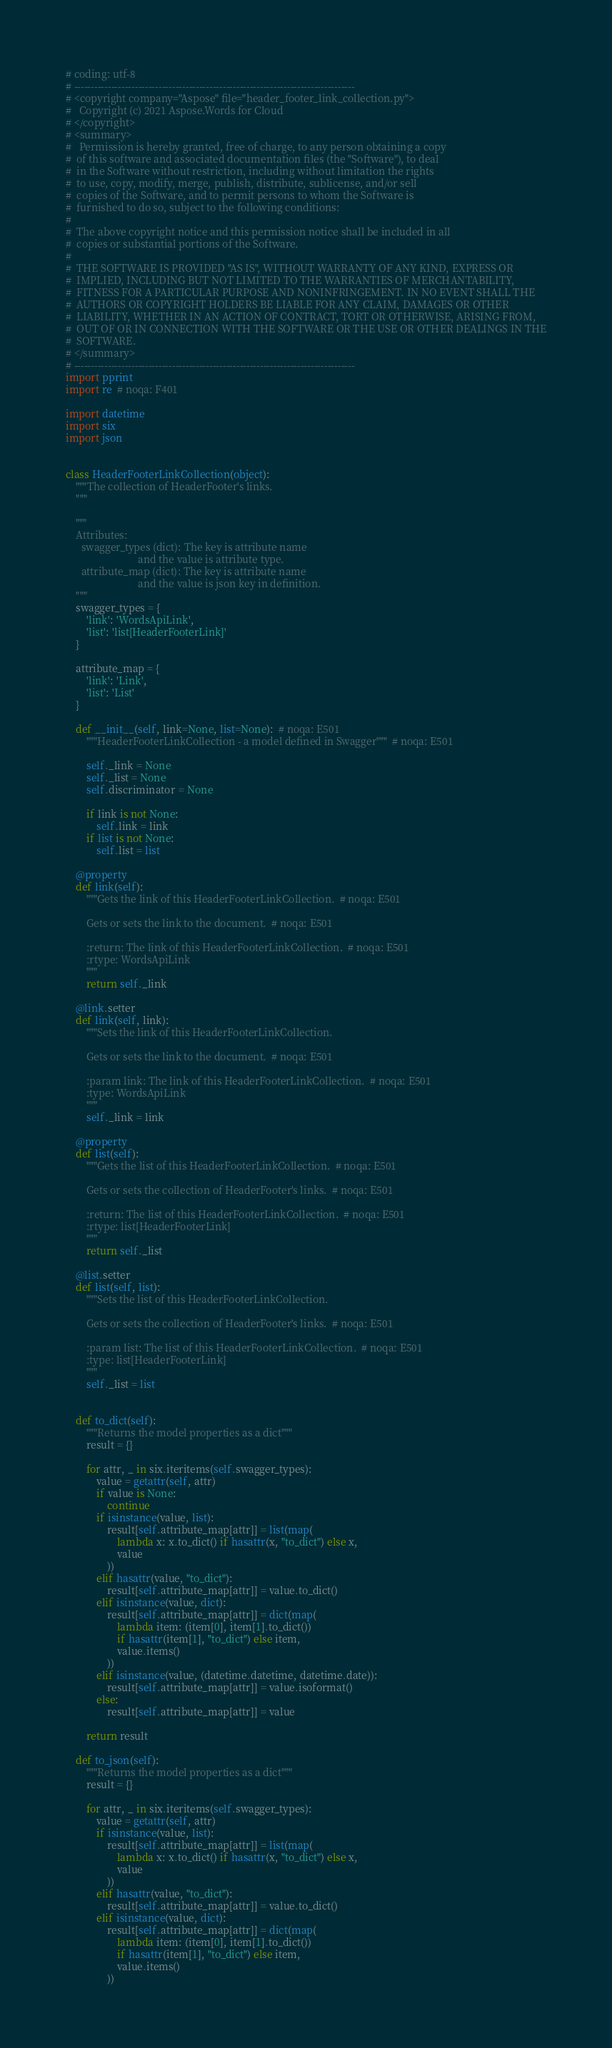Convert code to text. <code><loc_0><loc_0><loc_500><loc_500><_Python_># coding: utf-8
# -----------------------------------------------------------------------------------
# <copyright company="Aspose" file="header_footer_link_collection.py">
#   Copyright (c) 2021 Aspose.Words for Cloud
# </copyright>
# <summary>
#   Permission is hereby granted, free of charge, to any person obtaining a copy
#  of this software and associated documentation files (the "Software"), to deal
#  in the Software without restriction, including without limitation the rights
#  to use, copy, modify, merge, publish, distribute, sublicense, and/or sell
#  copies of the Software, and to permit persons to whom the Software is
#  furnished to do so, subject to the following conditions:
#
#  The above copyright notice and this permission notice shall be included in all
#  copies or substantial portions of the Software.
#
#  THE SOFTWARE IS PROVIDED "AS IS", WITHOUT WARRANTY OF ANY KIND, EXPRESS OR
#  IMPLIED, INCLUDING BUT NOT LIMITED TO THE WARRANTIES OF MERCHANTABILITY,
#  FITNESS FOR A PARTICULAR PURPOSE AND NONINFRINGEMENT. IN NO EVENT SHALL THE
#  AUTHORS OR COPYRIGHT HOLDERS BE LIABLE FOR ANY CLAIM, DAMAGES OR OTHER
#  LIABILITY, WHETHER IN AN ACTION OF CONTRACT, TORT OR OTHERWISE, ARISING FROM,
#  OUT OF OR IN CONNECTION WITH THE SOFTWARE OR THE USE OR OTHER DEALINGS IN THE
#  SOFTWARE.
# </summary>
# -----------------------------------------------------------------------------------
import pprint
import re  # noqa: F401

import datetime
import six
import json


class HeaderFooterLinkCollection(object):
    """The collection of HeaderFooter's links.
    """

    """
    Attributes:
      swagger_types (dict): The key is attribute name
                            and the value is attribute type.
      attribute_map (dict): The key is attribute name
                            and the value is json key in definition.
    """
    swagger_types = {
        'link': 'WordsApiLink',
        'list': 'list[HeaderFooterLink]'
    }

    attribute_map = {
        'link': 'Link',
        'list': 'List'
    }

    def __init__(self, link=None, list=None):  # noqa: E501
        """HeaderFooterLinkCollection - a model defined in Swagger"""  # noqa: E501

        self._link = None
        self._list = None
        self.discriminator = None

        if link is not None:
            self.link = link
        if list is not None:
            self.list = list

    @property
    def link(self):
        """Gets the link of this HeaderFooterLinkCollection.  # noqa: E501

        Gets or sets the link to the document.  # noqa: E501

        :return: The link of this HeaderFooterLinkCollection.  # noqa: E501
        :rtype: WordsApiLink
        """
        return self._link

    @link.setter
    def link(self, link):
        """Sets the link of this HeaderFooterLinkCollection.

        Gets or sets the link to the document.  # noqa: E501

        :param link: The link of this HeaderFooterLinkCollection.  # noqa: E501
        :type: WordsApiLink
        """
        self._link = link

    @property
    def list(self):
        """Gets the list of this HeaderFooterLinkCollection.  # noqa: E501

        Gets or sets the collection of HeaderFooter's links.  # noqa: E501

        :return: The list of this HeaderFooterLinkCollection.  # noqa: E501
        :rtype: list[HeaderFooterLink]
        """
        return self._list

    @list.setter
    def list(self, list):
        """Sets the list of this HeaderFooterLinkCollection.

        Gets or sets the collection of HeaderFooter's links.  # noqa: E501

        :param list: The list of this HeaderFooterLinkCollection.  # noqa: E501
        :type: list[HeaderFooterLink]
        """
        self._list = list


    def to_dict(self):
        """Returns the model properties as a dict"""
        result = {}

        for attr, _ in six.iteritems(self.swagger_types):
            value = getattr(self, attr)
            if value is None:
                continue
            if isinstance(value, list):
                result[self.attribute_map[attr]] = list(map(
                    lambda x: x.to_dict() if hasattr(x, "to_dict") else x,
                    value
                ))
            elif hasattr(value, "to_dict"):
                result[self.attribute_map[attr]] = value.to_dict()
            elif isinstance(value, dict):
                result[self.attribute_map[attr]] = dict(map(
                    lambda item: (item[0], item[1].to_dict())
                    if hasattr(item[1], "to_dict") else item,
                    value.items()
                ))
            elif isinstance(value, (datetime.datetime, datetime.date)):
                result[self.attribute_map[attr]] = value.isoformat()
            else:
                result[self.attribute_map[attr]] = value

        return result

    def to_json(self):
        """Returns the model properties as a dict"""
        result = {}

        for attr, _ in six.iteritems(self.swagger_types):
            value = getattr(self, attr)
            if isinstance(value, list):
                result[self.attribute_map[attr]] = list(map(
                    lambda x: x.to_dict() if hasattr(x, "to_dict") else x,
                    value
                ))
            elif hasattr(value, "to_dict"):
                result[self.attribute_map[attr]] = value.to_dict()
            elif isinstance(value, dict):
                result[self.attribute_map[attr]] = dict(map(
                    lambda item: (item[0], item[1].to_dict())
                    if hasattr(item[1], "to_dict") else item,
                    value.items()
                ))</code> 